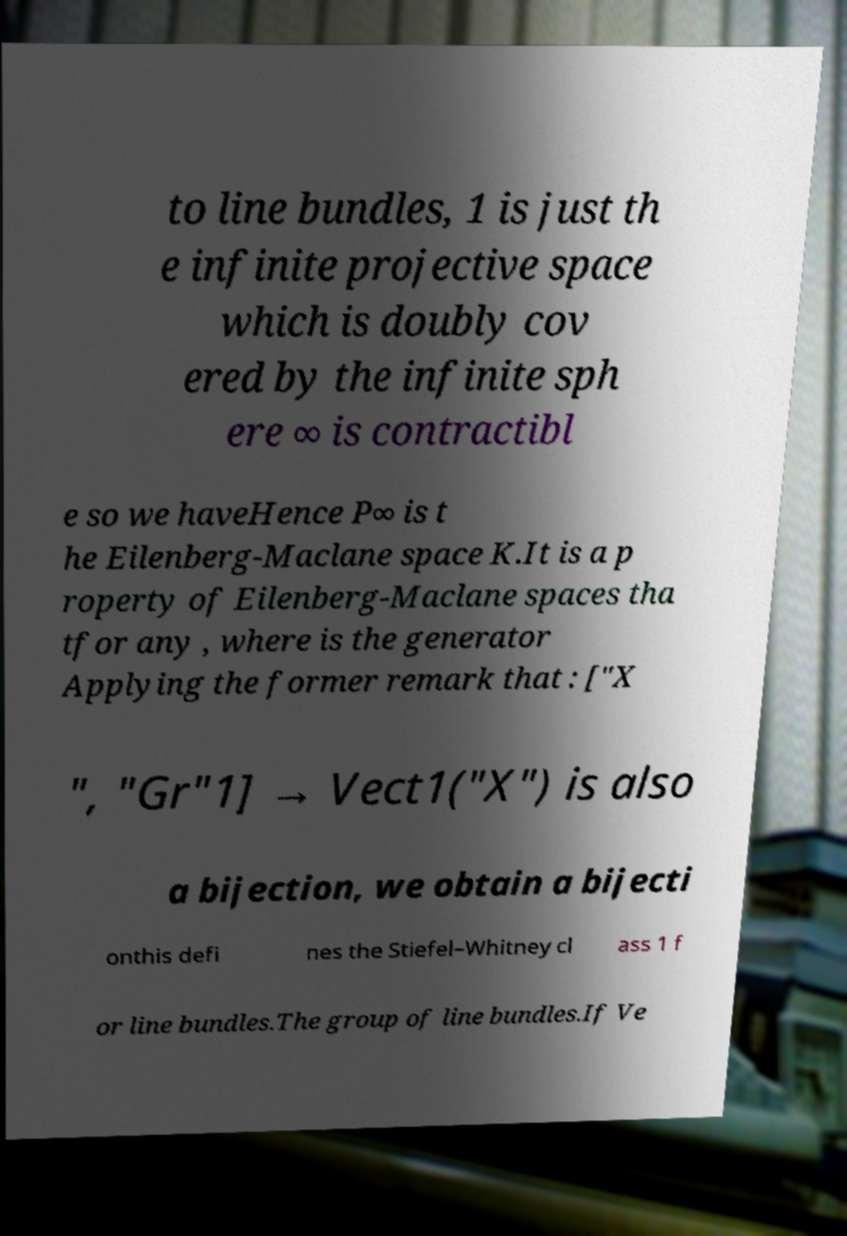Please identify and transcribe the text found in this image. to line bundles, 1 is just th e infinite projective space which is doubly cov ered by the infinite sph ere ∞ is contractibl e so we haveHence P∞ is t he Eilenberg-Maclane space K.It is a p roperty of Eilenberg-Maclane spaces tha tfor any , where is the generator Applying the former remark that : ["X ", "Gr"1] → Vect1("X") is also a bijection, we obtain a bijecti onthis defi nes the Stiefel–Whitney cl ass 1 f or line bundles.The group of line bundles.If Ve 